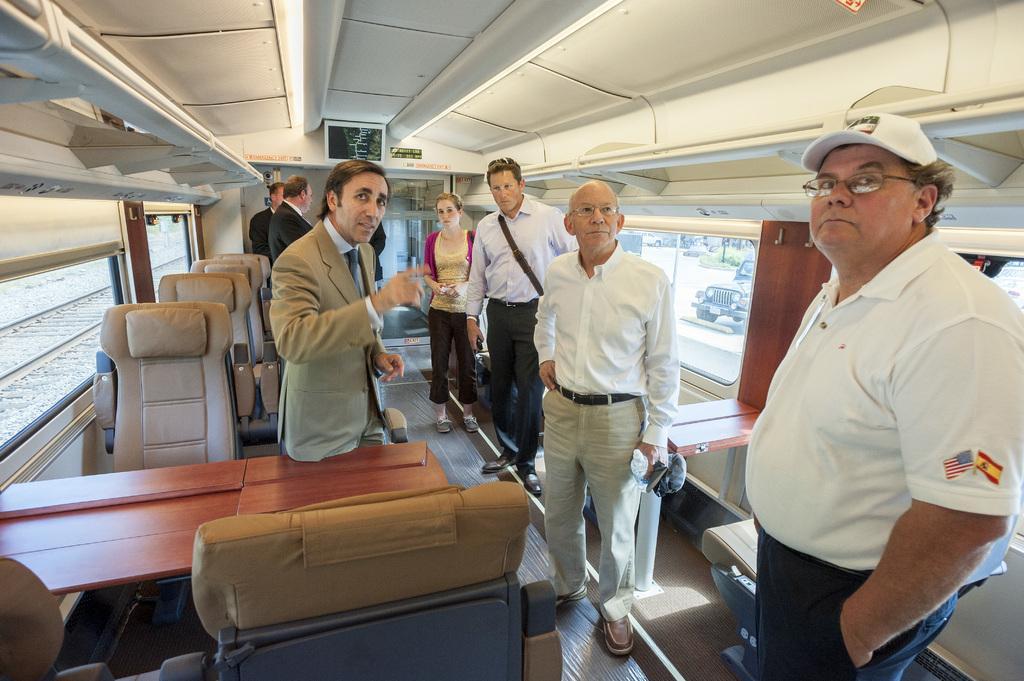In one or two sentences, can you explain what this image depicts? In the picture I can see people are standing on the floor. In the background I can see chairs, tables, ceiling, windows, a railway track, a vehicle and some other objects. 